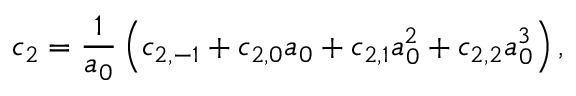<formula> <loc_0><loc_0><loc_500><loc_500>c _ { 2 } = \frac { 1 } { a _ { 0 } } \left ( c _ { 2 , - 1 } + c _ { 2 , 0 } a _ { 0 } + c _ { 2 , 1 } a _ { 0 } ^ { 2 } + c _ { 2 , 2 } a _ { 0 } ^ { 3 } \right ) ,</formula> 